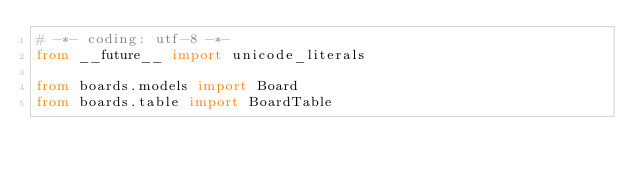<code> <loc_0><loc_0><loc_500><loc_500><_Python_># -*- coding: utf-8 -*-
from __future__ import unicode_literals

from boards.models import Board
from boards.table import BoardTable
</code> 